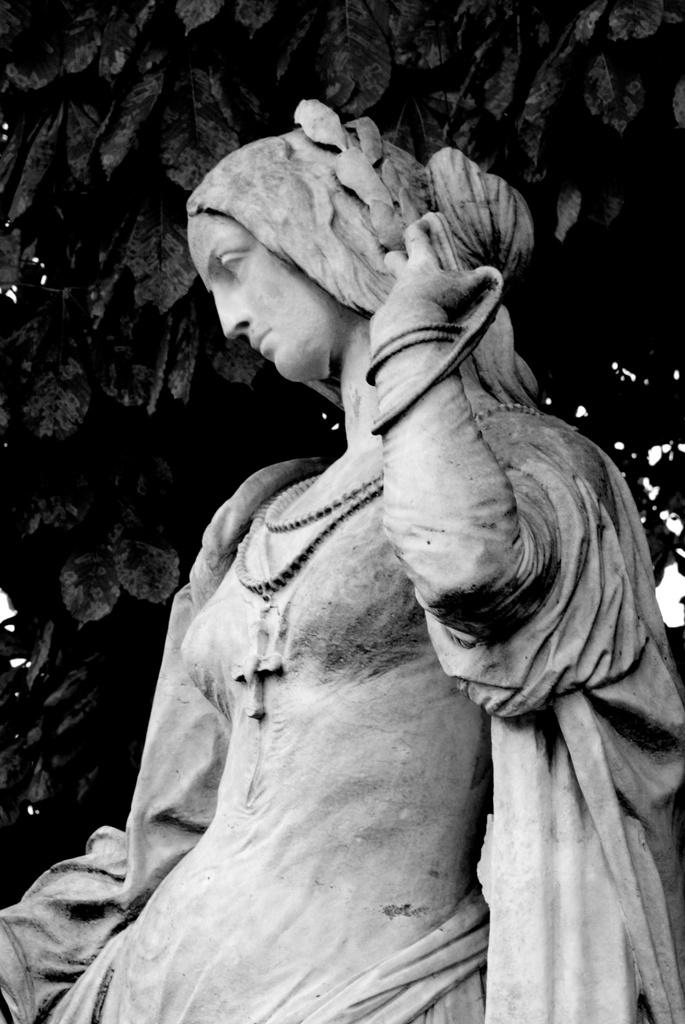What is the color scheme of the image? The image is black and white. What can be seen in the image besides the color scheme? There is a sculpture of a woman in the image. What can be seen in the background of the image? Leaves are visible in the background of the image. What type of coat is the woman wearing in the image? There is no coat visible in the image, as it is a sculpture of a woman and not a photograph or painting of a person wearing clothing. 